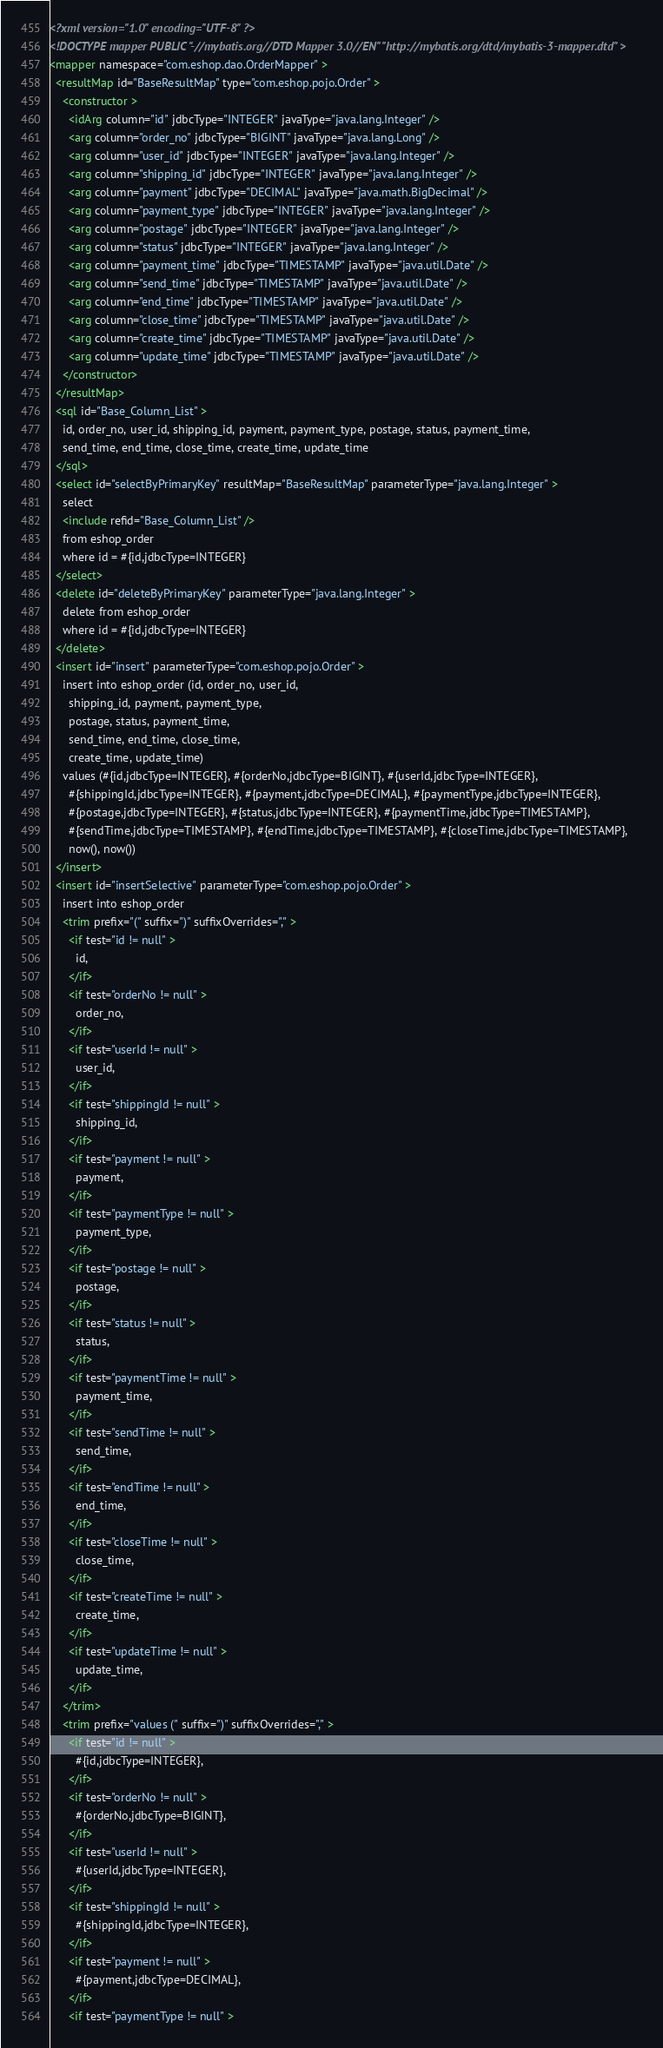<code> <loc_0><loc_0><loc_500><loc_500><_XML_><?xml version="1.0" encoding="UTF-8" ?>
<!DOCTYPE mapper PUBLIC "-//mybatis.org//DTD Mapper 3.0//EN" "http://mybatis.org/dtd/mybatis-3-mapper.dtd" >
<mapper namespace="com.eshop.dao.OrderMapper" >
  <resultMap id="BaseResultMap" type="com.eshop.pojo.Order" >
    <constructor >
      <idArg column="id" jdbcType="INTEGER" javaType="java.lang.Integer" />
      <arg column="order_no" jdbcType="BIGINT" javaType="java.lang.Long" />
      <arg column="user_id" jdbcType="INTEGER" javaType="java.lang.Integer" />
      <arg column="shipping_id" jdbcType="INTEGER" javaType="java.lang.Integer" />
      <arg column="payment" jdbcType="DECIMAL" javaType="java.math.BigDecimal" />
      <arg column="payment_type" jdbcType="INTEGER" javaType="java.lang.Integer" />
      <arg column="postage" jdbcType="INTEGER" javaType="java.lang.Integer" />
      <arg column="status" jdbcType="INTEGER" javaType="java.lang.Integer" />
      <arg column="payment_time" jdbcType="TIMESTAMP" javaType="java.util.Date" />
      <arg column="send_time" jdbcType="TIMESTAMP" javaType="java.util.Date" />
      <arg column="end_time" jdbcType="TIMESTAMP" javaType="java.util.Date" />
      <arg column="close_time" jdbcType="TIMESTAMP" javaType="java.util.Date" />
      <arg column="create_time" jdbcType="TIMESTAMP" javaType="java.util.Date" />
      <arg column="update_time" jdbcType="TIMESTAMP" javaType="java.util.Date" />
    </constructor>
  </resultMap>
  <sql id="Base_Column_List" >
    id, order_no, user_id, shipping_id, payment, payment_type, postage, status, payment_time, 
    send_time, end_time, close_time, create_time, update_time
  </sql>
  <select id="selectByPrimaryKey" resultMap="BaseResultMap" parameterType="java.lang.Integer" >
    select 
    <include refid="Base_Column_List" />
    from eshop_order
    where id = #{id,jdbcType=INTEGER}
  </select>
  <delete id="deleteByPrimaryKey" parameterType="java.lang.Integer" >
    delete from eshop_order
    where id = #{id,jdbcType=INTEGER}
  </delete>
  <insert id="insert" parameterType="com.eshop.pojo.Order" >
    insert into eshop_order (id, order_no, user_id, 
      shipping_id, payment, payment_type, 
      postage, status, payment_time, 
      send_time, end_time, close_time, 
      create_time, update_time)
    values (#{id,jdbcType=INTEGER}, #{orderNo,jdbcType=BIGINT}, #{userId,jdbcType=INTEGER}, 
      #{shippingId,jdbcType=INTEGER}, #{payment,jdbcType=DECIMAL}, #{paymentType,jdbcType=INTEGER}, 
      #{postage,jdbcType=INTEGER}, #{status,jdbcType=INTEGER}, #{paymentTime,jdbcType=TIMESTAMP}, 
      #{sendTime,jdbcType=TIMESTAMP}, #{endTime,jdbcType=TIMESTAMP}, #{closeTime,jdbcType=TIMESTAMP}, 
      now(), now())
  </insert>
  <insert id="insertSelective" parameterType="com.eshop.pojo.Order" >
    insert into eshop_order
    <trim prefix="(" suffix=")" suffixOverrides="," >
      <if test="id != null" >
        id,
      </if>
      <if test="orderNo != null" >
        order_no,
      </if>
      <if test="userId != null" >
        user_id,
      </if>
      <if test="shippingId != null" >
        shipping_id,
      </if>
      <if test="payment != null" >
        payment,
      </if>
      <if test="paymentType != null" >
        payment_type,
      </if>
      <if test="postage != null" >
        postage,
      </if>
      <if test="status != null" >
        status,
      </if>
      <if test="paymentTime != null" >
        payment_time,
      </if>
      <if test="sendTime != null" >
        send_time,
      </if>
      <if test="endTime != null" >
        end_time,
      </if>
      <if test="closeTime != null" >
        close_time,
      </if>
      <if test="createTime != null" >
        create_time,
      </if>
      <if test="updateTime != null" >
        update_time,
      </if>
    </trim>
    <trim prefix="values (" suffix=")" suffixOverrides="," >
      <if test="id != null" >
        #{id,jdbcType=INTEGER},
      </if>
      <if test="orderNo != null" >
        #{orderNo,jdbcType=BIGINT},
      </if>
      <if test="userId != null" >
        #{userId,jdbcType=INTEGER},
      </if>
      <if test="shippingId != null" >
        #{shippingId,jdbcType=INTEGER},
      </if>
      <if test="payment != null" >
        #{payment,jdbcType=DECIMAL},
      </if>
      <if test="paymentType != null" ></code> 